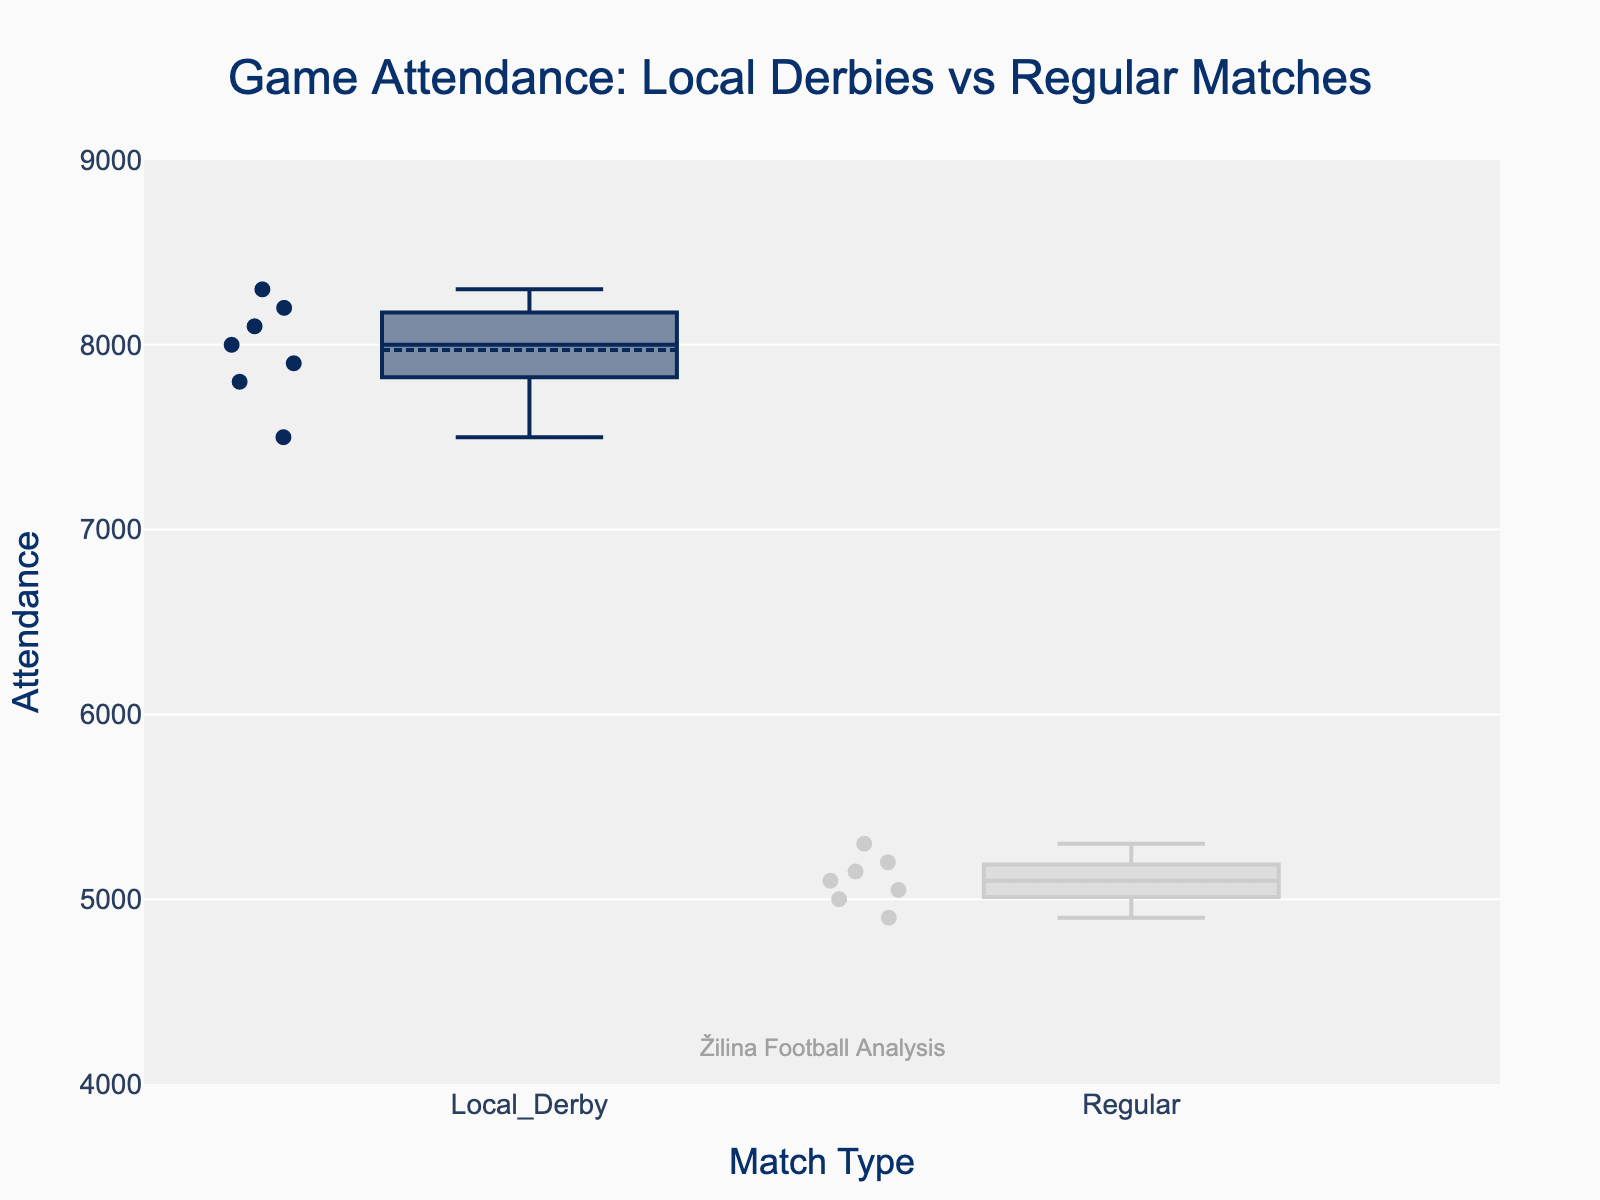What's the title of the figure? The title of the figure is located at the top and it describes the main topic or summary of the plot, which in this case is about game attendance for different types of matches.
Answer: Game Attendance: Local Derbies vs Regular Matches How many match types are being compared in the plot? Looking at the X-axis, there are two distinct labels indicating the comparison of two groups: "Local Derby" and "Regular."
Answer: Two Which type of match has higher median attendance? You can determine the median attendance by locating the middle line inside each box. The box representing "Local Derby" has a higher median line compared to "Regular."
Answer: Local Derby What is the median attendance for regular matches? The median in a box plot is represented by the line inside the box. For regular matches, this line is around the 5100 mark on the Y-axis.
Answer: 5100 What is the minimum attendance recorded for local derbies? The minimum attendance in a box plot is indicated by the lower whisker. For local derbies, this lower whisker touches the 7500 mark on the Y-axis.
Answer: 7500 Compare the interquartile ranges (IQR) of local derbies and regular matches. The IQR is the range between the first quartile (bottom of the box) and the third quartile (top of the box). For local derbies, the IQR is from about 7800 to 8200, and for regular matches, from about 5000 to 5200.
Answer: Local derbies have a larger IQR than regular matches What is the highest attendance recorded for regular matches? The highest attendance can be found at the top whisker of the box plot for regular matches. This mark is around the 5300 mark on the Y-axis.
Answer: 5300 How do the mean attendances of local derbies and regular matches compare? The mean attendance is represented by the dashed line inside each box. The mean for local derbies is higher than that for regular matches as it is positioned higher up on the Y-axis.
Answer: Local derbies have a higher mean attendance Which type of match shows more variation in attendance? Variation can be observed through the length of the whiskers and the spread of points. Local derbies show more variation as indicated by the wider range of the box and extended whiskers compared to regular matches.
Answer: Local derbies What is the range of attendance for each match type? The range is calculated by subtracting the minimum value from the maximum value. For local derbies, it is from 7500 to 8300, yielding a range of 800. For regular matches, it ranges from 4900 to 5300, yielding a range of 400.
Answer: Local derbies: 800, Regular matches: 400 